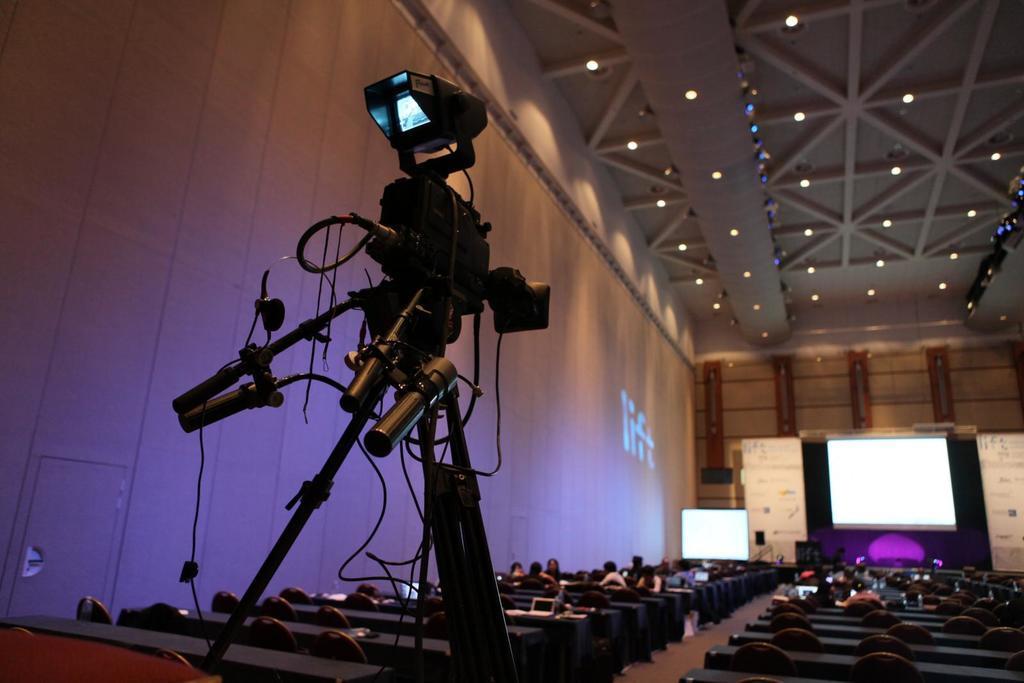Can you describe this image briefly? In this image I can see few people are sitting on the chairs. I can see few white color boards, screens, wall and few lights. In front I can see the camera on the stand. 